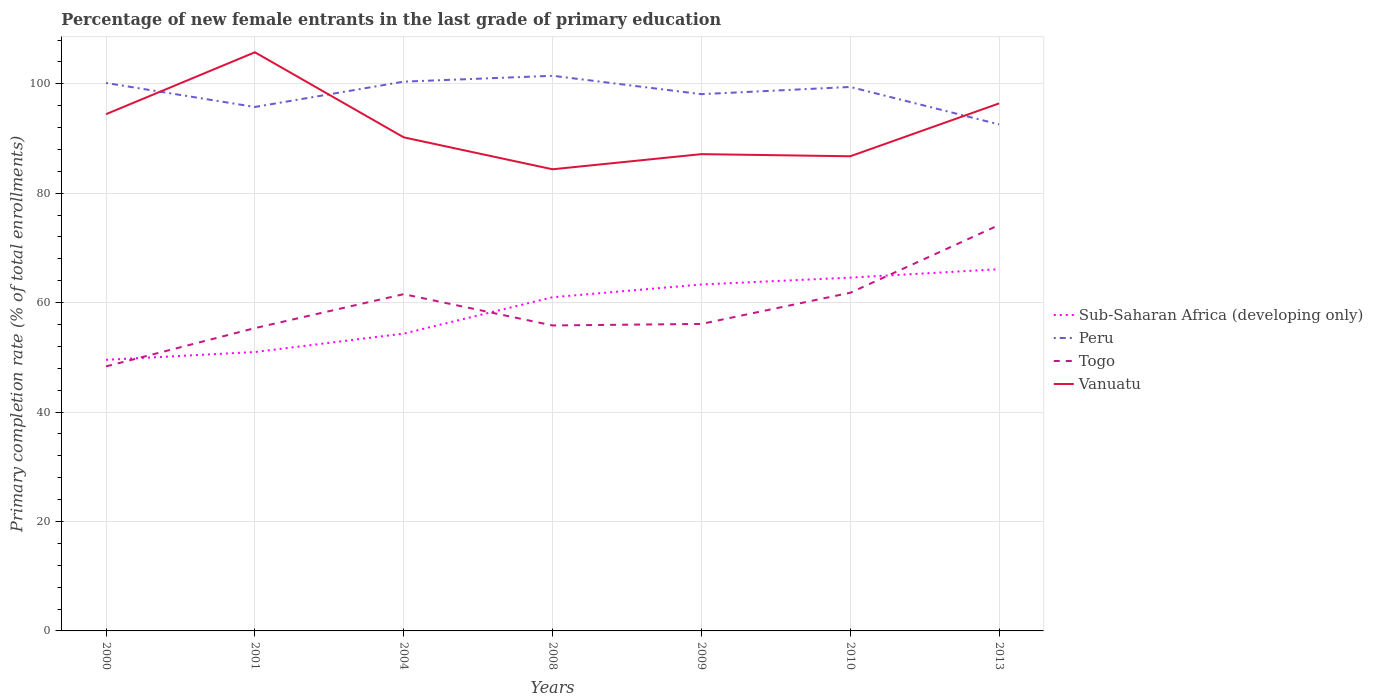Does the line corresponding to Peru intersect with the line corresponding to Togo?
Your answer should be compact. No. Across all years, what is the maximum percentage of new female entrants in Vanuatu?
Provide a succinct answer. 84.37. What is the total percentage of new female entrants in Peru in the graph?
Provide a succinct answer. -1.07. What is the difference between the highest and the second highest percentage of new female entrants in Peru?
Your answer should be very brief. 8.89. What is the difference between the highest and the lowest percentage of new female entrants in Vanuatu?
Your answer should be very brief. 3. How many years are there in the graph?
Offer a terse response. 7. Does the graph contain grids?
Give a very brief answer. Yes. What is the title of the graph?
Provide a short and direct response. Percentage of new female entrants in the last grade of primary education. What is the label or title of the Y-axis?
Offer a terse response. Primary completion rate (% of total enrollments). What is the Primary completion rate (% of total enrollments) in Sub-Saharan Africa (developing only) in 2000?
Keep it short and to the point. 49.55. What is the Primary completion rate (% of total enrollments) in Peru in 2000?
Your answer should be very brief. 100.15. What is the Primary completion rate (% of total enrollments) of Togo in 2000?
Ensure brevity in your answer.  48.34. What is the Primary completion rate (% of total enrollments) of Vanuatu in 2000?
Your response must be concise. 94.44. What is the Primary completion rate (% of total enrollments) in Sub-Saharan Africa (developing only) in 2001?
Offer a very short reply. 50.98. What is the Primary completion rate (% of total enrollments) of Peru in 2001?
Ensure brevity in your answer.  95.76. What is the Primary completion rate (% of total enrollments) in Togo in 2001?
Your response must be concise. 55.34. What is the Primary completion rate (% of total enrollments) in Vanuatu in 2001?
Ensure brevity in your answer.  105.76. What is the Primary completion rate (% of total enrollments) of Sub-Saharan Africa (developing only) in 2004?
Offer a terse response. 54.34. What is the Primary completion rate (% of total enrollments) of Peru in 2004?
Your response must be concise. 100.39. What is the Primary completion rate (% of total enrollments) of Togo in 2004?
Offer a very short reply. 61.55. What is the Primary completion rate (% of total enrollments) of Vanuatu in 2004?
Ensure brevity in your answer.  90.21. What is the Primary completion rate (% of total enrollments) in Sub-Saharan Africa (developing only) in 2008?
Make the answer very short. 60.99. What is the Primary completion rate (% of total enrollments) in Peru in 2008?
Offer a very short reply. 101.46. What is the Primary completion rate (% of total enrollments) of Togo in 2008?
Your answer should be compact. 55.83. What is the Primary completion rate (% of total enrollments) in Vanuatu in 2008?
Offer a very short reply. 84.37. What is the Primary completion rate (% of total enrollments) of Sub-Saharan Africa (developing only) in 2009?
Give a very brief answer. 63.32. What is the Primary completion rate (% of total enrollments) of Peru in 2009?
Ensure brevity in your answer.  98.1. What is the Primary completion rate (% of total enrollments) in Togo in 2009?
Make the answer very short. 56.11. What is the Primary completion rate (% of total enrollments) of Vanuatu in 2009?
Provide a succinct answer. 87.14. What is the Primary completion rate (% of total enrollments) in Sub-Saharan Africa (developing only) in 2010?
Provide a short and direct response. 64.57. What is the Primary completion rate (% of total enrollments) of Peru in 2010?
Keep it short and to the point. 99.42. What is the Primary completion rate (% of total enrollments) of Togo in 2010?
Your answer should be very brief. 61.81. What is the Primary completion rate (% of total enrollments) of Vanuatu in 2010?
Keep it short and to the point. 86.75. What is the Primary completion rate (% of total enrollments) of Sub-Saharan Africa (developing only) in 2013?
Ensure brevity in your answer.  66.11. What is the Primary completion rate (% of total enrollments) in Peru in 2013?
Ensure brevity in your answer.  92.57. What is the Primary completion rate (% of total enrollments) of Togo in 2013?
Offer a terse response. 74.2. What is the Primary completion rate (% of total enrollments) of Vanuatu in 2013?
Ensure brevity in your answer.  96.41. Across all years, what is the maximum Primary completion rate (% of total enrollments) of Sub-Saharan Africa (developing only)?
Keep it short and to the point. 66.11. Across all years, what is the maximum Primary completion rate (% of total enrollments) in Peru?
Give a very brief answer. 101.46. Across all years, what is the maximum Primary completion rate (% of total enrollments) of Togo?
Offer a very short reply. 74.2. Across all years, what is the maximum Primary completion rate (% of total enrollments) in Vanuatu?
Give a very brief answer. 105.76. Across all years, what is the minimum Primary completion rate (% of total enrollments) of Sub-Saharan Africa (developing only)?
Provide a succinct answer. 49.55. Across all years, what is the minimum Primary completion rate (% of total enrollments) of Peru?
Provide a succinct answer. 92.57. Across all years, what is the minimum Primary completion rate (% of total enrollments) in Togo?
Your response must be concise. 48.34. Across all years, what is the minimum Primary completion rate (% of total enrollments) of Vanuatu?
Your answer should be very brief. 84.37. What is the total Primary completion rate (% of total enrollments) of Sub-Saharan Africa (developing only) in the graph?
Keep it short and to the point. 409.85. What is the total Primary completion rate (% of total enrollments) in Peru in the graph?
Your answer should be very brief. 687.86. What is the total Primary completion rate (% of total enrollments) in Togo in the graph?
Make the answer very short. 413.18. What is the total Primary completion rate (% of total enrollments) in Vanuatu in the graph?
Your answer should be very brief. 645.09. What is the difference between the Primary completion rate (% of total enrollments) of Sub-Saharan Africa (developing only) in 2000 and that in 2001?
Your response must be concise. -1.43. What is the difference between the Primary completion rate (% of total enrollments) of Peru in 2000 and that in 2001?
Your answer should be very brief. 4.39. What is the difference between the Primary completion rate (% of total enrollments) of Togo in 2000 and that in 2001?
Keep it short and to the point. -7. What is the difference between the Primary completion rate (% of total enrollments) in Vanuatu in 2000 and that in 2001?
Offer a terse response. -11.31. What is the difference between the Primary completion rate (% of total enrollments) of Sub-Saharan Africa (developing only) in 2000 and that in 2004?
Provide a succinct answer. -4.79. What is the difference between the Primary completion rate (% of total enrollments) in Peru in 2000 and that in 2004?
Offer a very short reply. -0.24. What is the difference between the Primary completion rate (% of total enrollments) in Togo in 2000 and that in 2004?
Provide a succinct answer. -13.21. What is the difference between the Primary completion rate (% of total enrollments) in Vanuatu in 2000 and that in 2004?
Your response must be concise. 4.24. What is the difference between the Primary completion rate (% of total enrollments) in Sub-Saharan Africa (developing only) in 2000 and that in 2008?
Offer a terse response. -11.44. What is the difference between the Primary completion rate (% of total enrollments) in Peru in 2000 and that in 2008?
Provide a short and direct response. -1.31. What is the difference between the Primary completion rate (% of total enrollments) in Togo in 2000 and that in 2008?
Provide a short and direct response. -7.49. What is the difference between the Primary completion rate (% of total enrollments) in Vanuatu in 2000 and that in 2008?
Your response must be concise. 10.07. What is the difference between the Primary completion rate (% of total enrollments) in Sub-Saharan Africa (developing only) in 2000 and that in 2009?
Offer a very short reply. -13.77. What is the difference between the Primary completion rate (% of total enrollments) of Peru in 2000 and that in 2009?
Provide a succinct answer. 2.05. What is the difference between the Primary completion rate (% of total enrollments) in Togo in 2000 and that in 2009?
Keep it short and to the point. -7.77. What is the difference between the Primary completion rate (% of total enrollments) of Vanuatu in 2000 and that in 2009?
Keep it short and to the point. 7.3. What is the difference between the Primary completion rate (% of total enrollments) of Sub-Saharan Africa (developing only) in 2000 and that in 2010?
Ensure brevity in your answer.  -15.02. What is the difference between the Primary completion rate (% of total enrollments) of Peru in 2000 and that in 2010?
Keep it short and to the point. 0.73. What is the difference between the Primary completion rate (% of total enrollments) of Togo in 2000 and that in 2010?
Your response must be concise. -13.46. What is the difference between the Primary completion rate (% of total enrollments) of Vanuatu in 2000 and that in 2010?
Offer a very short reply. 7.69. What is the difference between the Primary completion rate (% of total enrollments) in Sub-Saharan Africa (developing only) in 2000 and that in 2013?
Your answer should be compact. -16.57. What is the difference between the Primary completion rate (% of total enrollments) in Peru in 2000 and that in 2013?
Your answer should be very brief. 7.57. What is the difference between the Primary completion rate (% of total enrollments) in Togo in 2000 and that in 2013?
Provide a succinct answer. -25.86. What is the difference between the Primary completion rate (% of total enrollments) in Vanuatu in 2000 and that in 2013?
Make the answer very short. -1.97. What is the difference between the Primary completion rate (% of total enrollments) in Sub-Saharan Africa (developing only) in 2001 and that in 2004?
Provide a short and direct response. -3.36. What is the difference between the Primary completion rate (% of total enrollments) in Peru in 2001 and that in 2004?
Provide a succinct answer. -4.63. What is the difference between the Primary completion rate (% of total enrollments) in Togo in 2001 and that in 2004?
Make the answer very short. -6.2. What is the difference between the Primary completion rate (% of total enrollments) in Vanuatu in 2001 and that in 2004?
Provide a succinct answer. 15.55. What is the difference between the Primary completion rate (% of total enrollments) in Sub-Saharan Africa (developing only) in 2001 and that in 2008?
Your response must be concise. -10.01. What is the difference between the Primary completion rate (% of total enrollments) in Peru in 2001 and that in 2008?
Ensure brevity in your answer.  -5.7. What is the difference between the Primary completion rate (% of total enrollments) in Togo in 2001 and that in 2008?
Your answer should be very brief. -0.48. What is the difference between the Primary completion rate (% of total enrollments) of Vanuatu in 2001 and that in 2008?
Offer a very short reply. 21.38. What is the difference between the Primary completion rate (% of total enrollments) of Sub-Saharan Africa (developing only) in 2001 and that in 2009?
Your response must be concise. -12.34. What is the difference between the Primary completion rate (% of total enrollments) of Peru in 2001 and that in 2009?
Give a very brief answer. -2.34. What is the difference between the Primary completion rate (% of total enrollments) in Togo in 2001 and that in 2009?
Keep it short and to the point. -0.76. What is the difference between the Primary completion rate (% of total enrollments) in Vanuatu in 2001 and that in 2009?
Give a very brief answer. 18.62. What is the difference between the Primary completion rate (% of total enrollments) in Sub-Saharan Africa (developing only) in 2001 and that in 2010?
Ensure brevity in your answer.  -13.6. What is the difference between the Primary completion rate (% of total enrollments) of Peru in 2001 and that in 2010?
Provide a short and direct response. -3.66. What is the difference between the Primary completion rate (% of total enrollments) in Togo in 2001 and that in 2010?
Give a very brief answer. -6.46. What is the difference between the Primary completion rate (% of total enrollments) of Vanuatu in 2001 and that in 2010?
Provide a succinct answer. 19. What is the difference between the Primary completion rate (% of total enrollments) of Sub-Saharan Africa (developing only) in 2001 and that in 2013?
Ensure brevity in your answer.  -15.14. What is the difference between the Primary completion rate (% of total enrollments) in Peru in 2001 and that in 2013?
Provide a short and direct response. 3.19. What is the difference between the Primary completion rate (% of total enrollments) in Togo in 2001 and that in 2013?
Keep it short and to the point. -18.85. What is the difference between the Primary completion rate (% of total enrollments) in Vanuatu in 2001 and that in 2013?
Keep it short and to the point. 9.34. What is the difference between the Primary completion rate (% of total enrollments) of Sub-Saharan Africa (developing only) in 2004 and that in 2008?
Provide a succinct answer. -6.64. What is the difference between the Primary completion rate (% of total enrollments) in Peru in 2004 and that in 2008?
Make the answer very short. -1.07. What is the difference between the Primary completion rate (% of total enrollments) of Togo in 2004 and that in 2008?
Make the answer very short. 5.72. What is the difference between the Primary completion rate (% of total enrollments) in Vanuatu in 2004 and that in 2008?
Your response must be concise. 5.84. What is the difference between the Primary completion rate (% of total enrollments) of Sub-Saharan Africa (developing only) in 2004 and that in 2009?
Provide a succinct answer. -8.98. What is the difference between the Primary completion rate (% of total enrollments) in Peru in 2004 and that in 2009?
Ensure brevity in your answer.  2.29. What is the difference between the Primary completion rate (% of total enrollments) in Togo in 2004 and that in 2009?
Give a very brief answer. 5.44. What is the difference between the Primary completion rate (% of total enrollments) of Vanuatu in 2004 and that in 2009?
Your response must be concise. 3.07. What is the difference between the Primary completion rate (% of total enrollments) in Sub-Saharan Africa (developing only) in 2004 and that in 2010?
Ensure brevity in your answer.  -10.23. What is the difference between the Primary completion rate (% of total enrollments) of Peru in 2004 and that in 2010?
Make the answer very short. 0.97. What is the difference between the Primary completion rate (% of total enrollments) in Togo in 2004 and that in 2010?
Offer a terse response. -0.26. What is the difference between the Primary completion rate (% of total enrollments) of Vanuatu in 2004 and that in 2010?
Give a very brief answer. 3.46. What is the difference between the Primary completion rate (% of total enrollments) in Sub-Saharan Africa (developing only) in 2004 and that in 2013?
Ensure brevity in your answer.  -11.77. What is the difference between the Primary completion rate (% of total enrollments) of Peru in 2004 and that in 2013?
Make the answer very short. 7.82. What is the difference between the Primary completion rate (% of total enrollments) of Togo in 2004 and that in 2013?
Offer a very short reply. -12.65. What is the difference between the Primary completion rate (% of total enrollments) in Vanuatu in 2004 and that in 2013?
Ensure brevity in your answer.  -6.2. What is the difference between the Primary completion rate (% of total enrollments) in Sub-Saharan Africa (developing only) in 2008 and that in 2009?
Make the answer very short. -2.33. What is the difference between the Primary completion rate (% of total enrollments) in Peru in 2008 and that in 2009?
Provide a succinct answer. 3.36. What is the difference between the Primary completion rate (% of total enrollments) in Togo in 2008 and that in 2009?
Make the answer very short. -0.28. What is the difference between the Primary completion rate (% of total enrollments) in Vanuatu in 2008 and that in 2009?
Your answer should be compact. -2.77. What is the difference between the Primary completion rate (% of total enrollments) in Sub-Saharan Africa (developing only) in 2008 and that in 2010?
Make the answer very short. -3.59. What is the difference between the Primary completion rate (% of total enrollments) of Peru in 2008 and that in 2010?
Ensure brevity in your answer.  2.04. What is the difference between the Primary completion rate (% of total enrollments) of Togo in 2008 and that in 2010?
Offer a terse response. -5.98. What is the difference between the Primary completion rate (% of total enrollments) of Vanuatu in 2008 and that in 2010?
Give a very brief answer. -2.38. What is the difference between the Primary completion rate (% of total enrollments) of Sub-Saharan Africa (developing only) in 2008 and that in 2013?
Give a very brief answer. -5.13. What is the difference between the Primary completion rate (% of total enrollments) in Peru in 2008 and that in 2013?
Provide a succinct answer. 8.89. What is the difference between the Primary completion rate (% of total enrollments) in Togo in 2008 and that in 2013?
Your answer should be compact. -18.37. What is the difference between the Primary completion rate (% of total enrollments) of Vanuatu in 2008 and that in 2013?
Ensure brevity in your answer.  -12.04. What is the difference between the Primary completion rate (% of total enrollments) in Sub-Saharan Africa (developing only) in 2009 and that in 2010?
Provide a succinct answer. -1.25. What is the difference between the Primary completion rate (% of total enrollments) of Peru in 2009 and that in 2010?
Ensure brevity in your answer.  -1.32. What is the difference between the Primary completion rate (% of total enrollments) of Togo in 2009 and that in 2010?
Offer a terse response. -5.7. What is the difference between the Primary completion rate (% of total enrollments) in Vanuatu in 2009 and that in 2010?
Your response must be concise. 0.39. What is the difference between the Primary completion rate (% of total enrollments) of Sub-Saharan Africa (developing only) in 2009 and that in 2013?
Provide a short and direct response. -2.79. What is the difference between the Primary completion rate (% of total enrollments) in Peru in 2009 and that in 2013?
Ensure brevity in your answer.  5.53. What is the difference between the Primary completion rate (% of total enrollments) in Togo in 2009 and that in 2013?
Keep it short and to the point. -18.09. What is the difference between the Primary completion rate (% of total enrollments) in Vanuatu in 2009 and that in 2013?
Your response must be concise. -9.27. What is the difference between the Primary completion rate (% of total enrollments) in Sub-Saharan Africa (developing only) in 2010 and that in 2013?
Ensure brevity in your answer.  -1.54. What is the difference between the Primary completion rate (% of total enrollments) in Peru in 2010 and that in 2013?
Offer a very short reply. 6.85. What is the difference between the Primary completion rate (% of total enrollments) in Togo in 2010 and that in 2013?
Your answer should be compact. -12.39. What is the difference between the Primary completion rate (% of total enrollments) of Vanuatu in 2010 and that in 2013?
Your answer should be very brief. -9.66. What is the difference between the Primary completion rate (% of total enrollments) in Sub-Saharan Africa (developing only) in 2000 and the Primary completion rate (% of total enrollments) in Peru in 2001?
Provide a succinct answer. -46.22. What is the difference between the Primary completion rate (% of total enrollments) of Sub-Saharan Africa (developing only) in 2000 and the Primary completion rate (% of total enrollments) of Togo in 2001?
Provide a succinct answer. -5.8. What is the difference between the Primary completion rate (% of total enrollments) in Sub-Saharan Africa (developing only) in 2000 and the Primary completion rate (% of total enrollments) in Vanuatu in 2001?
Give a very brief answer. -56.21. What is the difference between the Primary completion rate (% of total enrollments) of Peru in 2000 and the Primary completion rate (% of total enrollments) of Togo in 2001?
Keep it short and to the point. 44.8. What is the difference between the Primary completion rate (% of total enrollments) in Peru in 2000 and the Primary completion rate (% of total enrollments) in Vanuatu in 2001?
Your response must be concise. -5.61. What is the difference between the Primary completion rate (% of total enrollments) in Togo in 2000 and the Primary completion rate (% of total enrollments) in Vanuatu in 2001?
Keep it short and to the point. -57.41. What is the difference between the Primary completion rate (% of total enrollments) of Sub-Saharan Africa (developing only) in 2000 and the Primary completion rate (% of total enrollments) of Peru in 2004?
Keep it short and to the point. -50.84. What is the difference between the Primary completion rate (% of total enrollments) in Sub-Saharan Africa (developing only) in 2000 and the Primary completion rate (% of total enrollments) in Togo in 2004?
Offer a terse response. -12. What is the difference between the Primary completion rate (% of total enrollments) of Sub-Saharan Africa (developing only) in 2000 and the Primary completion rate (% of total enrollments) of Vanuatu in 2004?
Keep it short and to the point. -40.66. What is the difference between the Primary completion rate (% of total enrollments) in Peru in 2000 and the Primary completion rate (% of total enrollments) in Togo in 2004?
Offer a terse response. 38.6. What is the difference between the Primary completion rate (% of total enrollments) in Peru in 2000 and the Primary completion rate (% of total enrollments) in Vanuatu in 2004?
Your response must be concise. 9.94. What is the difference between the Primary completion rate (% of total enrollments) in Togo in 2000 and the Primary completion rate (% of total enrollments) in Vanuatu in 2004?
Provide a succinct answer. -41.87. What is the difference between the Primary completion rate (% of total enrollments) in Sub-Saharan Africa (developing only) in 2000 and the Primary completion rate (% of total enrollments) in Peru in 2008?
Your response must be concise. -51.91. What is the difference between the Primary completion rate (% of total enrollments) in Sub-Saharan Africa (developing only) in 2000 and the Primary completion rate (% of total enrollments) in Togo in 2008?
Offer a very short reply. -6.28. What is the difference between the Primary completion rate (% of total enrollments) of Sub-Saharan Africa (developing only) in 2000 and the Primary completion rate (% of total enrollments) of Vanuatu in 2008?
Provide a succinct answer. -34.83. What is the difference between the Primary completion rate (% of total enrollments) of Peru in 2000 and the Primary completion rate (% of total enrollments) of Togo in 2008?
Provide a short and direct response. 44.32. What is the difference between the Primary completion rate (% of total enrollments) of Peru in 2000 and the Primary completion rate (% of total enrollments) of Vanuatu in 2008?
Your answer should be very brief. 15.78. What is the difference between the Primary completion rate (% of total enrollments) of Togo in 2000 and the Primary completion rate (% of total enrollments) of Vanuatu in 2008?
Your response must be concise. -36.03. What is the difference between the Primary completion rate (% of total enrollments) in Sub-Saharan Africa (developing only) in 2000 and the Primary completion rate (% of total enrollments) in Peru in 2009?
Your response must be concise. -48.55. What is the difference between the Primary completion rate (% of total enrollments) in Sub-Saharan Africa (developing only) in 2000 and the Primary completion rate (% of total enrollments) in Togo in 2009?
Make the answer very short. -6.56. What is the difference between the Primary completion rate (% of total enrollments) of Sub-Saharan Africa (developing only) in 2000 and the Primary completion rate (% of total enrollments) of Vanuatu in 2009?
Your answer should be compact. -37.59. What is the difference between the Primary completion rate (% of total enrollments) in Peru in 2000 and the Primary completion rate (% of total enrollments) in Togo in 2009?
Provide a short and direct response. 44.04. What is the difference between the Primary completion rate (% of total enrollments) in Peru in 2000 and the Primary completion rate (% of total enrollments) in Vanuatu in 2009?
Give a very brief answer. 13.01. What is the difference between the Primary completion rate (% of total enrollments) of Togo in 2000 and the Primary completion rate (% of total enrollments) of Vanuatu in 2009?
Offer a very short reply. -38.8. What is the difference between the Primary completion rate (% of total enrollments) of Sub-Saharan Africa (developing only) in 2000 and the Primary completion rate (% of total enrollments) of Peru in 2010?
Give a very brief answer. -49.87. What is the difference between the Primary completion rate (% of total enrollments) in Sub-Saharan Africa (developing only) in 2000 and the Primary completion rate (% of total enrollments) in Togo in 2010?
Give a very brief answer. -12.26. What is the difference between the Primary completion rate (% of total enrollments) in Sub-Saharan Africa (developing only) in 2000 and the Primary completion rate (% of total enrollments) in Vanuatu in 2010?
Make the answer very short. -37.2. What is the difference between the Primary completion rate (% of total enrollments) in Peru in 2000 and the Primary completion rate (% of total enrollments) in Togo in 2010?
Your answer should be very brief. 38.34. What is the difference between the Primary completion rate (% of total enrollments) of Peru in 2000 and the Primary completion rate (% of total enrollments) of Vanuatu in 2010?
Your response must be concise. 13.4. What is the difference between the Primary completion rate (% of total enrollments) of Togo in 2000 and the Primary completion rate (% of total enrollments) of Vanuatu in 2010?
Your answer should be very brief. -38.41. What is the difference between the Primary completion rate (% of total enrollments) in Sub-Saharan Africa (developing only) in 2000 and the Primary completion rate (% of total enrollments) in Peru in 2013?
Give a very brief answer. -43.03. What is the difference between the Primary completion rate (% of total enrollments) of Sub-Saharan Africa (developing only) in 2000 and the Primary completion rate (% of total enrollments) of Togo in 2013?
Your answer should be very brief. -24.65. What is the difference between the Primary completion rate (% of total enrollments) in Sub-Saharan Africa (developing only) in 2000 and the Primary completion rate (% of total enrollments) in Vanuatu in 2013?
Offer a very short reply. -46.87. What is the difference between the Primary completion rate (% of total enrollments) of Peru in 2000 and the Primary completion rate (% of total enrollments) of Togo in 2013?
Provide a succinct answer. 25.95. What is the difference between the Primary completion rate (% of total enrollments) of Peru in 2000 and the Primary completion rate (% of total enrollments) of Vanuatu in 2013?
Your response must be concise. 3.74. What is the difference between the Primary completion rate (% of total enrollments) of Togo in 2000 and the Primary completion rate (% of total enrollments) of Vanuatu in 2013?
Provide a short and direct response. -48.07. What is the difference between the Primary completion rate (% of total enrollments) in Sub-Saharan Africa (developing only) in 2001 and the Primary completion rate (% of total enrollments) in Peru in 2004?
Ensure brevity in your answer.  -49.41. What is the difference between the Primary completion rate (% of total enrollments) in Sub-Saharan Africa (developing only) in 2001 and the Primary completion rate (% of total enrollments) in Togo in 2004?
Your response must be concise. -10.57. What is the difference between the Primary completion rate (% of total enrollments) in Sub-Saharan Africa (developing only) in 2001 and the Primary completion rate (% of total enrollments) in Vanuatu in 2004?
Keep it short and to the point. -39.23. What is the difference between the Primary completion rate (% of total enrollments) of Peru in 2001 and the Primary completion rate (% of total enrollments) of Togo in 2004?
Offer a very short reply. 34.21. What is the difference between the Primary completion rate (% of total enrollments) in Peru in 2001 and the Primary completion rate (% of total enrollments) in Vanuatu in 2004?
Give a very brief answer. 5.55. What is the difference between the Primary completion rate (% of total enrollments) of Togo in 2001 and the Primary completion rate (% of total enrollments) of Vanuatu in 2004?
Offer a very short reply. -34.86. What is the difference between the Primary completion rate (% of total enrollments) of Sub-Saharan Africa (developing only) in 2001 and the Primary completion rate (% of total enrollments) of Peru in 2008?
Provide a short and direct response. -50.49. What is the difference between the Primary completion rate (% of total enrollments) in Sub-Saharan Africa (developing only) in 2001 and the Primary completion rate (% of total enrollments) in Togo in 2008?
Ensure brevity in your answer.  -4.85. What is the difference between the Primary completion rate (% of total enrollments) in Sub-Saharan Africa (developing only) in 2001 and the Primary completion rate (% of total enrollments) in Vanuatu in 2008?
Give a very brief answer. -33.4. What is the difference between the Primary completion rate (% of total enrollments) of Peru in 2001 and the Primary completion rate (% of total enrollments) of Togo in 2008?
Your answer should be compact. 39.93. What is the difference between the Primary completion rate (% of total enrollments) of Peru in 2001 and the Primary completion rate (% of total enrollments) of Vanuatu in 2008?
Give a very brief answer. 11.39. What is the difference between the Primary completion rate (% of total enrollments) in Togo in 2001 and the Primary completion rate (% of total enrollments) in Vanuatu in 2008?
Your response must be concise. -29.03. What is the difference between the Primary completion rate (% of total enrollments) in Sub-Saharan Africa (developing only) in 2001 and the Primary completion rate (% of total enrollments) in Peru in 2009?
Keep it short and to the point. -47.13. What is the difference between the Primary completion rate (% of total enrollments) in Sub-Saharan Africa (developing only) in 2001 and the Primary completion rate (% of total enrollments) in Togo in 2009?
Offer a very short reply. -5.13. What is the difference between the Primary completion rate (% of total enrollments) in Sub-Saharan Africa (developing only) in 2001 and the Primary completion rate (% of total enrollments) in Vanuatu in 2009?
Provide a short and direct response. -36.16. What is the difference between the Primary completion rate (% of total enrollments) in Peru in 2001 and the Primary completion rate (% of total enrollments) in Togo in 2009?
Offer a very short reply. 39.65. What is the difference between the Primary completion rate (% of total enrollments) of Peru in 2001 and the Primary completion rate (% of total enrollments) of Vanuatu in 2009?
Your response must be concise. 8.62. What is the difference between the Primary completion rate (% of total enrollments) of Togo in 2001 and the Primary completion rate (% of total enrollments) of Vanuatu in 2009?
Your answer should be very brief. -31.8. What is the difference between the Primary completion rate (% of total enrollments) of Sub-Saharan Africa (developing only) in 2001 and the Primary completion rate (% of total enrollments) of Peru in 2010?
Offer a terse response. -48.44. What is the difference between the Primary completion rate (% of total enrollments) in Sub-Saharan Africa (developing only) in 2001 and the Primary completion rate (% of total enrollments) in Togo in 2010?
Your response must be concise. -10.83. What is the difference between the Primary completion rate (% of total enrollments) of Sub-Saharan Africa (developing only) in 2001 and the Primary completion rate (% of total enrollments) of Vanuatu in 2010?
Provide a short and direct response. -35.78. What is the difference between the Primary completion rate (% of total enrollments) in Peru in 2001 and the Primary completion rate (% of total enrollments) in Togo in 2010?
Ensure brevity in your answer.  33.96. What is the difference between the Primary completion rate (% of total enrollments) of Peru in 2001 and the Primary completion rate (% of total enrollments) of Vanuatu in 2010?
Offer a very short reply. 9.01. What is the difference between the Primary completion rate (% of total enrollments) in Togo in 2001 and the Primary completion rate (% of total enrollments) in Vanuatu in 2010?
Keep it short and to the point. -31.41. What is the difference between the Primary completion rate (% of total enrollments) of Sub-Saharan Africa (developing only) in 2001 and the Primary completion rate (% of total enrollments) of Peru in 2013?
Give a very brief answer. -41.6. What is the difference between the Primary completion rate (% of total enrollments) in Sub-Saharan Africa (developing only) in 2001 and the Primary completion rate (% of total enrollments) in Togo in 2013?
Offer a terse response. -23.22. What is the difference between the Primary completion rate (% of total enrollments) of Sub-Saharan Africa (developing only) in 2001 and the Primary completion rate (% of total enrollments) of Vanuatu in 2013?
Your response must be concise. -45.44. What is the difference between the Primary completion rate (% of total enrollments) in Peru in 2001 and the Primary completion rate (% of total enrollments) in Togo in 2013?
Provide a succinct answer. 21.56. What is the difference between the Primary completion rate (% of total enrollments) in Peru in 2001 and the Primary completion rate (% of total enrollments) in Vanuatu in 2013?
Your response must be concise. -0.65. What is the difference between the Primary completion rate (% of total enrollments) of Togo in 2001 and the Primary completion rate (% of total enrollments) of Vanuatu in 2013?
Provide a short and direct response. -41.07. What is the difference between the Primary completion rate (% of total enrollments) of Sub-Saharan Africa (developing only) in 2004 and the Primary completion rate (% of total enrollments) of Peru in 2008?
Provide a short and direct response. -47.12. What is the difference between the Primary completion rate (% of total enrollments) of Sub-Saharan Africa (developing only) in 2004 and the Primary completion rate (% of total enrollments) of Togo in 2008?
Give a very brief answer. -1.49. What is the difference between the Primary completion rate (% of total enrollments) of Sub-Saharan Africa (developing only) in 2004 and the Primary completion rate (% of total enrollments) of Vanuatu in 2008?
Ensure brevity in your answer.  -30.03. What is the difference between the Primary completion rate (% of total enrollments) in Peru in 2004 and the Primary completion rate (% of total enrollments) in Togo in 2008?
Your answer should be compact. 44.56. What is the difference between the Primary completion rate (% of total enrollments) of Peru in 2004 and the Primary completion rate (% of total enrollments) of Vanuatu in 2008?
Offer a very short reply. 16.02. What is the difference between the Primary completion rate (% of total enrollments) of Togo in 2004 and the Primary completion rate (% of total enrollments) of Vanuatu in 2008?
Your answer should be compact. -22.82. What is the difference between the Primary completion rate (% of total enrollments) of Sub-Saharan Africa (developing only) in 2004 and the Primary completion rate (% of total enrollments) of Peru in 2009?
Your response must be concise. -43.76. What is the difference between the Primary completion rate (% of total enrollments) of Sub-Saharan Africa (developing only) in 2004 and the Primary completion rate (% of total enrollments) of Togo in 2009?
Offer a very short reply. -1.77. What is the difference between the Primary completion rate (% of total enrollments) in Sub-Saharan Africa (developing only) in 2004 and the Primary completion rate (% of total enrollments) in Vanuatu in 2009?
Ensure brevity in your answer.  -32.8. What is the difference between the Primary completion rate (% of total enrollments) of Peru in 2004 and the Primary completion rate (% of total enrollments) of Togo in 2009?
Give a very brief answer. 44.28. What is the difference between the Primary completion rate (% of total enrollments) of Peru in 2004 and the Primary completion rate (% of total enrollments) of Vanuatu in 2009?
Your answer should be very brief. 13.25. What is the difference between the Primary completion rate (% of total enrollments) in Togo in 2004 and the Primary completion rate (% of total enrollments) in Vanuatu in 2009?
Provide a short and direct response. -25.59. What is the difference between the Primary completion rate (% of total enrollments) in Sub-Saharan Africa (developing only) in 2004 and the Primary completion rate (% of total enrollments) in Peru in 2010?
Give a very brief answer. -45.08. What is the difference between the Primary completion rate (% of total enrollments) of Sub-Saharan Africa (developing only) in 2004 and the Primary completion rate (% of total enrollments) of Togo in 2010?
Provide a short and direct response. -7.47. What is the difference between the Primary completion rate (% of total enrollments) of Sub-Saharan Africa (developing only) in 2004 and the Primary completion rate (% of total enrollments) of Vanuatu in 2010?
Your answer should be very brief. -32.41. What is the difference between the Primary completion rate (% of total enrollments) in Peru in 2004 and the Primary completion rate (% of total enrollments) in Togo in 2010?
Your response must be concise. 38.58. What is the difference between the Primary completion rate (% of total enrollments) of Peru in 2004 and the Primary completion rate (% of total enrollments) of Vanuatu in 2010?
Offer a very short reply. 13.64. What is the difference between the Primary completion rate (% of total enrollments) of Togo in 2004 and the Primary completion rate (% of total enrollments) of Vanuatu in 2010?
Ensure brevity in your answer.  -25.2. What is the difference between the Primary completion rate (% of total enrollments) of Sub-Saharan Africa (developing only) in 2004 and the Primary completion rate (% of total enrollments) of Peru in 2013?
Provide a short and direct response. -38.23. What is the difference between the Primary completion rate (% of total enrollments) in Sub-Saharan Africa (developing only) in 2004 and the Primary completion rate (% of total enrollments) in Togo in 2013?
Give a very brief answer. -19.86. What is the difference between the Primary completion rate (% of total enrollments) of Sub-Saharan Africa (developing only) in 2004 and the Primary completion rate (% of total enrollments) of Vanuatu in 2013?
Provide a short and direct response. -42.07. What is the difference between the Primary completion rate (% of total enrollments) in Peru in 2004 and the Primary completion rate (% of total enrollments) in Togo in 2013?
Your response must be concise. 26.19. What is the difference between the Primary completion rate (% of total enrollments) in Peru in 2004 and the Primary completion rate (% of total enrollments) in Vanuatu in 2013?
Ensure brevity in your answer.  3.98. What is the difference between the Primary completion rate (% of total enrollments) in Togo in 2004 and the Primary completion rate (% of total enrollments) in Vanuatu in 2013?
Keep it short and to the point. -34.86. What is the difference between the Primary completion rate (% of total enrollments) of Sub-Saharan Africa (developing only) in 2008 and the Primary completion rate (% of total enrollments) of Peru in 2009?
Your answer should be compact. -37.12. What is the difference between the Primary completion rate (% of total enrollments) in Sub-Saharan Africa (developing only) in 2008 and the Primary completion rate (% of total enrollments) in Togo in 2009?
Provide a short and direct response. 4.88. What is the difference between the Primary completion rate (% of total enrollments) of Sub-Saharan Africa (developing only) in 2008 and the Primary completion rate (% of total enrollments) of Vanuatu in 2009?
Offer a very short reply. -26.16. What is the difference between the Primary completion rate (% of total enrollments) of Peru in 2008 and the Primary completion rate (% of total enrollments) of Togo in 2009?
Provide a succinct answer. 45.35. What is the difference between the Primary completion rate (% of total enrollments) in Peru in 2008 and the Primary completion rate (% of total enrollments) in Vanuatu in 2009?
Offer a terse response. 14.32. What is the difference between the Primary completion rate (% of total enrollments) in Togo in 2008 and the Primary completion rate (% of total enrollments) in Vanuatu in 2009?
Offer a terse response. -31.31. What is the difference between the Primary completion rate (% of total enrollments) of Sub-Saharan Africa (developing only) in 2008 and the Primary completion rate (% of total enrollments) of Peru in 2010?
Your answer should be very brief. -38.43. What is the difference between the Primary completion rate (% of total enrollments) of Sub-Saharan Africa (developing only) in 2008 and the Primary completion rate (% of total enrollments) of Togo in 2010?
Your answer should be compact. -0.82. What is the difference between the Primary completion rate (% of total enrollments) of Sub-Saharan Africa (developing only) in 2008 and the Primary completion rate (% of total enrollments) of Vanuatu in 2010?
Your response must be concise. -25.77. What is the difference between the Primary completion rate (% of total enrollments) of Peru in 2008 and the Primary completion rate (% of total enrollments) of Togo in 2010?
Provide a short and direct response. 39.66. What is the difference between the Primary completion rate (% of total enrollments) of Peru in 2008 and the Primary completion rate (% of total enrollments) of Vanuatu in 2010?
Your response must be concise. 14.71. What is the difference between the Primary completion rate (% of total enrollments) in Togo in 2008 and the Primary completion rate (% of total enrollments) in Vanuatu in 2010?
Your answer should be very brief. -30.92. What is the difference between the Primary completion rate (% of total enrollments) of Sub-Saharan Africa (developing only) in 2008 and the Primary completion rate (% of total enrollments) of Peru in 2013?
Offer a terse response. -31.59. What is the difference between the Primary completion rate (% of total enrollments) of Sub-Saharan Africa (developing only) in 2008 and the Primary completion rate (% of total enrollments) of Togo in 2013?
Offer a very short reply. -13.21. What is the difference between the Primary completion rate (% of total enrollments) of Sub-Saharan Africa (developing only) in 2008 and the Primary completion rate (% of total enrollments) of Vanuatu in 2013?
Ensure brevity in your answer.  -35.43. What is the difference between the Primary completion rate (% of total enrollments) in Peru in 2008 and the Primary completion rate (% of total enrollments) in Togo in 2013?
Make the answer very short. 27.26. What is the difference between the Primary completion rate (% of total enrollments) in Peru in 2008 and the Primary completion rate (% of total enrollments) in Vanuatu in 2013?
Keep it short and to the point. 5.05. What is the difference between the Primary completion rate (% of total enrollments) in Togo in 2008 and the Primary completion rate (% of total enrollments) in Vanuatu in 2013?
Your answer should be compact. -40.58. What is the difference between the Primary completion rate (% of total enrollments) in Sub-Saharan Africa (developing only) in 2009 and the Primary completion rate (% of total enrollments) in Peru in 2010?
Make the answer very short. -36.1. What is the difference between the Primary completion rate (% of total enrollments) of Sub-Saharan Africa (developing only) in 2009 and the Primary completion rate (% of total enrollments) of Togo in 2010?
Your response must be concise. 1.51. What is the difference between the Primary completion rate (% of total enrollments) in Sub-Saharan Africa (developing only) in 2009 and the Primary completion rate (% of total enrollments) in Vanuatu in 2010?
Ensure brevity in your answer.  -23.43. What is the difference between the Primary completion rate (% of total enrollments) of Peru in 2009 and the Primary completion rate (% of total enrollments) of Togo in 2010?
Give a very brief answer. 36.3. What is the difference between the Primary completion rate (% of total enrollments) in Peru in 2009 and the Primary completion rate (% of total enrollments) in Vanuatu in 2010?
Offer a very short reply. 11.35. What is the difference between the Primary completion rate (% of total enrollments) in Togo in 2009 and the Primary completion rate (% of total enrollments) in Vanuatu in 2010?
Provide a succinct answer. -30.64. What is the difference between the Primary completion rate (% of total enrollments) of Sub-Saharan Africa (developing only) in 2009 and the Primary completion rate (% of total enrollments) of Peru in 2013?
Offer a very short reply. -29.25. What is the difference between the Primary completion rate (% of total enrollments) in Sub-Saharan Africa (developing only) in 2009 and the Primary completion rate (% of total enrollments) in Togo in 2013?
Keep it short and to the point. -10.88. What is the difference between the Primary completion rate (% of total enrollments) in Sub-Saharan Africa (developing only) in 2009 and the Primary completion rate (% of total enrollments) in Vanuatu in 2013?
Your answer should be compact. -33.09. What is the difference between the Primary completion rate (% of total enrollments) in Peru in 2009 and the Primary completion rate (% of total enrollments) in Togo in 2013?
Offer a terse response. 23.9. What is the difference between the Primary completion rate (% of total enrollments) in Peru in 2009 and the Primary completion rate (% of total enrollments) in Vanuatu in 2013?
Give a very brief answer. 1.69. What is the difference between the Primary completion rate (% of total enrollments) of Togo in 2009 and the Primary completion rate (% of total enrollments) of Vanuatu in 2013?
Provide a succinct answer. -40.3. What is the difference between the Primary completion rate (% of total enrollments) in Sub-Saharan Africa (developing only) in 2010 and the Primary completion rate (% of total enrollments) in Peru in 2013?
Offer a terse response. -28. What is the difference between the Primary completion rate (% of total enrollments) of Sub-Saharan Africa (developing only) in 2010 and the Primary completion rate (% of total enrollments) of Togo in 2013?
Your answer should be very brief. -9.63. What is the difference between the Primary completion rate (% of total enrollments) of Sub-Saharan Africa (developing only) in 2010 and the Primary completion rate (% of total enrollments) of Vanuatu in 2013?
Give a very brief answer. -31.84. What is the difference between the Primary completion rate (% of total enrollments) in Peru in 2010 and the Primary completion rate (% of total enrollments) in Togo in 2013?
Ensure brevity in your answer.  25.22. What is the difference between the Primary completion rate (% of total enrollments) in Peru in 2010 and the Primary completion rate (% of total enrollments) in Vanuatu in 2013?
Make the answer very short. 3.01. What is the difference between the Primary completion rate (% of total enrollments) of Togo in 2010 and the Primary completion rate (% of total enrollments) of Vanuatu in 2013?
Give a very brief answer. -34.61. What is the average Primary completion rate (% of total enrollments) in Sub-Saharan Africa (developing only) per year?
Provide a short and direct response. 58.55. What is the average Primary completion rate (% of total enrollments) of Peru per year?
Keep it short and to the point. 98.27. What is the average Primary completion rate (% of total enrollments) of Togo per year?
Ensure brevity in your answer.  59.03. What is the average Primary completion rate (% of total enrollments) in Vanuatu per year?
Ensure brevity in your answer.  92.16. In the year 2000, what is the difference between the Primary completion rate (% of total enrollments) of Sub-Saharan Africa (developing only) and Primary completion rate (% of total enrollments) of Peru?
Make the answer very short. -50.6. In the year 2000, what is the difference between the Primary completion rate (% of total enrollments) in Sub-Saharan Africa (developing only) and Primary completion rate (% of total enrollments) in Togo?
Your answer should be very brief. 1.2. In the year 2000, what is the difference between the Primary completion rate (% of total enrollments) of Sub-Saharan Africa (developing only) and Primary completion rate (% of total enrollments) of Vanuatu?
Give a very brief answer. -44.9. In the year 2000, what is the difference between the Primary completion rate (% of total enrollments) in Peru and Primary completion rate (% of total enrollments) in Togo?
Keep it short and to the point. 51.8. In the year 2000, what is the difference between the Primary completion rate (% of total enrollments) in Peru and Primary completion rate (% of total enrollments) in Vanuatu?
Your answer should be compact. 5.7. In the year 2000, what is the difference between the Primary completion rate (% of total enrollments) in Togo and Primary completion rate (% of total enrollments) in Vanuatu?
Offer a terse response. -46.1. In the year 2001, what is the difference between the Primary completion rate (% of total enrollments) in Sub-Saharan Africa (developing only) and Primary completion rate (% of total enrollments) in Peru?
Offer a very short reply. -44.79. In the year 2001, what is the difference between the Primary completion rate (% of total enrollments) in Sub-Saharan Africa (developing only) and Primary completion rate (% of total enrollments) in Togo?
Offer a very short reply. -4.37. In the year 2001, what is the difference between the Primary completion rate (% of total enrollments) in Sub-Saharan Africa (developing only) and Primary completion rate (% of total enrollments) in Vanuatu?
Keep it short and to the point. -54.78. In the year 2001, what is the difference between the Primary completion rate (% of total enrollments) of Peru and Primary completion rate (% of total enrollments) of Togo?
Your response must be concise. 40.42. In the year 2001, what is the difference between the Primary completion rate (% of total enrollments) in Peru and Primary completion rate (% of total enrollments) in Vanuatu?
Provide a succinct answer. -9.99. In the year 2001, what is the difference between the Primary completion rate (% of total enrollments) in Togo and Primary completion rate (% of total enrollments) in Vanuatu?
Offer a very short reply. -50.41. In the year 2004, what is the difference between the Primary completion rate (% of total enrollments) of Sub-Saharan Africa (developing only) and Primary completion rate (% of total enrollments) of Peru?
Your answer should be compact. -46.05. In the year 2004, what is the difference between the Primary completion rate (% of total enrollments) of Sub-Saharan Africa (developing only) and Primary completion rate (% of total enrollments) of Togo?
Provide a short and direct response. -7.21. In the year 2004, what is the difference between the Primary completion rate (% of total enrollments) in Sub-Saharan Africa (developing only) and Primary completion rate (% of total enrollments) in Vanuatu?
Offer a terse response. -35.87. In the year 2004, what is the difference between the Primary completion rate (% of total enrollments) of Peru and Primary completion rate (% of total enrollments) of Togo?
Your answer should be very brief. 38.84. In the year 2004, what is the difference between the Primary completion rate (% of total enrollments) in Peru and Primary completion rate (% of total enrollments) in Vanuatu?
Offer a terse response. 10.18. In the year 2004, what is the difference between the Primary completion rate (% of total enrollments) in Togo and Primary completion rate (% of total enrollments) in Vanuatu?
Offer a very short reply. -28.66. In the year 2008, what is the difference between the Primary completion rate (% of total enrollments) of Sub-Saharan Africa (developing only) and Primary completion rate (% of total enrollments) of Peru?
Ensure brevity in your answer.  -40.48. In the year 2008, what is the difference between the Primary completion rate (% of total enrollments) of Sub-Saharan Africa (developing only) and Primary completion rate (% of total enrollments) of Togo?
Your answer should be compact. 5.16. In the year 2008, what is the difference between the Primary completion rate (% of total enrollments) in Sub-Saharan Africa (developing only) and Primary completion rate (% of total enrollments) in Vanuatu?
Your answer should be very brief. -23.39. In the year 2008, what is the difference between the Primary completion rate (% of total enrollments) of Peru and Primary completion rate (% of total enrollments) of Togo?
Your response must be concise. 45.63. In the year 2008, what is the difference between the Primary completion rate (% of total enrollments) in Peru and Primary completion rate (% of total enrollments) in Vanuatu?
Your response must be concise. 17.09. In the year 2008, what is the difference between the Primary completion rate (% of total enrollments) in Togo and Primary completion rate (% of total enrollments) in Vanuatu?
Give a very brief answer. -28.54. In the year 2009, what is the difference between the Primary completion rate (% of total enrollments) in Sub-Saharan Africa (developing only) and Primary completion rate (% of total enrollments) in Peru?
Ensure brevity in your answer.  -34.78. In the year 2009, what is the difference between the Primary completion rate (% of total enrollments) in Sub-Saharan Africa (developing only) and Primary completion rate (% of total enrollments) in Togo?
Offer a very short reply. 7.21. In the year 2009, what is the difference between the Primary completion rate (% of total enrollments) of Sub-Saharan Africa (developing only) and Primary completion rate (% of total enrollments) of Vanuatu?
Provide a short and direct response. -23.82. In the year 2009, what is the difference between the Primary completion rate (% of total enrollments) of Peru and Primary completion rate (% of total enrollments) of Togo?
Your answer should be compact. 41.99. In the year 2009, what is the difference between the Primary completion rate (% of total enrollments) of Peru and Primary completion rate (% of total enrollments) of Vanuatu?
Your answer should be compact. 10.96. In the year 2009, what is the difference between the Primary completion rate (% of total enrollments) in Togo and Primary completion rate (% of total enrollments) in Vanuatu?
Ensure brevity in your answer.  -31.03. In the year 2010, what is the difference between the Primary completion rate (% of total enrollments) of Sub-Saharan Africa (developing only) and Primary completion rate (% of total enrollments) of Peru?
Your answer should be compact. -34.85. In the year 2010, what is the difference between the Primary completion rate (% of total enrollments) in Sub-Saharan Africa (developing only) and Primary completion rate (% of total enrollments) in Togo?
Offer a terse response. 2.77. In the year 2010, what is the difference between the Primary completion rate (% of total enrollments) in Sub-Saharan Africa (developing only) and Primary completion rate (% of total enrollments) in Vanuatu?
Your answer should be very brief. -22.18. In the year 2010, what is the difference between the Primary completion rate (% of total enrollments) of Peru and Primary completion rate (% of total enrollments) of Togo?
Offer a very short reply. 37.61. In the year 2010, what is the difference between the Primary completion rate (% of total enrollments) in Peru and Primary completion rate (% of total enrollments) in Vanuatu?
Keep it short and to the point. 12.67. In the year 2010, what is the difference between the Primary completion rate (% of total enrollments) of Togo and Primary completion rate (% of total enrollments) of Vanuatu?
Your response must be concise. -24.95. In the year 2013, what is the difference between the Primary completion rate (% of total enrollments) in Sub-Saharan Africa (developing only) and Primary completion rate (% of total enrollments) in Peru?
Offer a terse response. -26.46. In the year 2013, what is the difference between the Primary completion rate (% of total enrollments) in Sub-Saharan Africa (developing only) and Primary completion rate (% of total enrollments) in Togo?
Offer a very short reply. -8.09. In the year 2013, what is the difference between the Primary completion rate (% of total enrollments) in Sub-Saharan Africa (developing only) and Primary completion rate (% of total enrollments) in Vanuatu?
Your answer should be very brief. -30.3. In the year 2013, what is the difference between the Primary completion rate (% of total enrollments) of Peru and Primary completion rate (% of total enrollments) of Togo?
Your response must be concise. 18.37. In the year 2013, what is the difference between the Primary completion rate (% of total enrollments) of Peru and Primary completion rate (% of total enrollments) of Vanuatu?
Give a very brief answer. -3.84. In the year 2013, what is the difference between the Primary completion rate (% of total enrollments) in Togo and Primary completion rate (% of total enrollments) in Vanuatu?
Your answer should be very brief. -22.21. What is the ratio of the Primary completion rate (% of total enrollments) of Sub-Saharan Africa (developing only) in 2000 to that in 2001?
Keep it short and to the point. 0.97. What is the ratio of the Primary completion rate (% of total enrollments) in Peru in 2000 to that in 2001?
Your answer should be compact. 1.05. What is the ratio of the Primary completion rate (% of total enrollments) of Togo in 2000 to that in 2001?
Provide a short and direct response. 0.87. What is the ratio of the Primary completion rate (% of total enrollments) of Vanuatu in 2000 to that in 2001?
Your response must be concise. 0.89. What is the ratio of the Primary completion rate (% of total enrollments) in Sub-Saharan Africa (developing only) in 2000 to that in 2004?
Your response must be concise. 0.91. What is the ratio of the Primary completion rate (% of total enrollments) in Togo in 2000 to that in 2004?
Keep it short and to the point. 0.79. What is the ratio of the Primary completion rate (% of total enrollments) of Vanuatu in 2000 to that in 2004?
Provide a short and direct response. 1.05. What is the ratio of the Primary completion rate (% of total enrollments) of Sub-Saharan Africa (developing only) in 2000 to that in 2008?
Your answer should be very brief. 0.81. What is the ratio of the Primary completion rate (% of total enrollments) of Togo in 2000 to that in 2008?
Give a very brief answer. 0.87. What is the ratio of the Primary completion rate (% of total enrollments) in Vanuatu in 2000 to that in 2008?
Ensure brevity in your answer.  1.12. What is the ratio of the Primary completion rate (% of total enrollments) of Sub-Saharan Africa (developing only) in 2000 to that in 2009?
Your response must be concise. 0.78. What is the ratio of the Primary completion rate (% of total enrollments) in Peru in 2000 to that in 2009?
Give a very brief answer. 1.02. What is the ratio of the Primary completion rate (% of total enrollments) in Togo in 2000 to that in 2009?
Provide a short and direct response. 0.86. What is the ratio of the Primary completion rate (% of total enrollments) in Vanuatu in 2000 to that in 2009?
Give a very brief answer. 1.08. What is the ratio of the Primary completion rate (% of total enrollments) of Sub-Saharan Africa (developing only) in 2000 to that in 2010?
Offer a terse response. 0.77. What is the ratio of the Primary completion rate (% of total enrollments) in Peru in 2000 to that in 2010?
Ensure brevity in your answer.  1.01. What is the ratio of the Primary completion rate (% of total enrollments) in Togo in 2000 to that in 2010?
Your answer should be very brief. 0.78. What is the ratio of the Primary completion rate (% of total enrollments) in Vanuatu in 2000 to that in 2010?
Keep it short and to the point. 1.09. What is the ratio of the Primary completion rate (% of total enrollments) in Sub-Saharan Africa (developing only) in 2000 to that in 2013?
Give a very brief answer. 0.75. What is the ratio of the Primary completion rate (% of total enrollments) of Peru in 2000 to that in 2013?
Offer a very short reply. 1.08. What is the ratio of the Primary completion rate (% of total enrollments) in Togo in 2000 to that in 2013?
Keep it short and to the point. 0.65. What is the ratio of the Primary completion rate (% of total enrollments) in Vanuatu in 2000 to that in 2013?
Ensure brevity in your answer.  0.98. What is the ratio of the Primary completion rate (% of total enrollments) in Sub-Saharan Africa (developing only) in 2001 to that in 2004?
Provide a short and direct response. 0.94. What is the ratio of the Primary completion rate (% of total enrollments) in Peru in 2001 to that in 2004?
Make the answer very short. 0.95. What is the ratio of the Primary completion rate (% of total enrollments) in Togo in 2001 to that in 2004?
Ensure brevity in your answer.  0.9. What is the ratio of the Primary completion rate (% of total enrollments) in Vanuatu in 2001 to that in 2004?
Your response must be concise. 1.17. What is the ratio of the Primary completion rate (% of total enrollments) of Sub-Saharan Africa (developing only) in 2001 to that in 2008?
Give a very brief answer. 0.84. What is the ratio of the Primary completion rate (% of total enrollments) of Peru in 2001 to that in 2008?
Ensure brevity in your answer.  0.94. What is the ratio of the Primary completion rate (% of total enrollments) in Togo in 2001 to that in 2008?
Your answer should be compact. 0.99. What is the ratio of the Primary completion rate (% of total enrollments) in Vanuatu in 2001 to that in 2008?
Your answer should be compact. 1.25. What is the ratio of the Primary completion rate (% of total enrollments) of Sub-Saharan Africa (developing only) in 2001 to that in 2009?
Offer a terse response. 0.81. What is the ratio of the Primary completion rate (% of total enrollments) of Peru in 2001 to that in 2009?
Your answer should be compact. 0.98. What is the ratio of the Primary completion rate (% of total enrollments) of Togo in 2001 to that in 2009?
Ensure brevity in your answer.  0.99. What is the ratio of the Primary completion rate (% of total enrollments) of Vanuatu in 2001 to that in 2009?
Your answer should be very brief. 1.21. What is the ratio of the Primary completion rate (% of total enrollments) of Sub-Saharan Africa (developing only) in 2001 to that in 2010?
Keep it short and to the point. 0.79. What is the ratio of the Primary completion rate (% of total enrollments) in Peru in 2001 to that in 2010?
Make the answer very short. 0.96. What is the ratio of the Primary completion rate (% of total enrollments) of Togo in 2001 to that in 2010?
Provide a short and direct response. 0.9. What is the ratio of the Primary completion rate (% of total enrollments) of Vanuatu in 2001 to that in 2010?
Make the answer very short. 1.22. What is the ratio of the Primary completion rate (% of total enrollments) of Sub-Saharan Africa (developing only) in 2001 to that in 2013?
Your answer should be very brief. 0.77. What is the ratio of the Primary completion rate (% of total enrollments) in Peru in 2001 to that in 2013?
Your answer should be compact. 1.03. What is the ratio of the Primary completion rate (% of total enrollments) of Togo in 2001 to that in 2013?
Give a very brief answer. 0.75. What is the ratio of the Primary completion rate (% of total enrollments) of Vanuatu in 2001 to that in 2013?
Your answer should be compact. 1.1. What is the ratio of the Primary completion rate (% of total enrollments) of Sub-Saharan Africa (developing only) in 2004 to that in 2008?
Make the answer very short. 0.89. What is the ratio of the Primary completion rate (% of total enrollments) of Peru in 2004 to that in 2008?
Your answer should be compact. 0.99. What is the ratio of the Primary completion rate (% of total enrollments) in Togo in 2004 to that in 2008?
Your response must be concise. 1.1. What is the ratio of the Primary completion rate (% of total enrollments) of Vanuatu in 2004 to that in 2008?
Ensure brevity in your answer.  1.07. What is the ratio of the Primary completion rate (% of total enrollments) in Sub-Saharan Africa (developing only) in 2004 to that in 2009?
Provide a short and direct response. 0.86. What is the ratio of the Primary completion rate (% of total enrollments) of Peru in 2004 to that in 2009?
Ensure brevity in your answer.  1.02. What is the ratio of the Primary completion rate (% of total enrollments) in Togo in 2004 to that in 2009?
Provide a succinct answer. 1.1. What is the ratio of the Primary completion rate (% of total enrollments) of Vanuatu in 2004 to that in 2009?
Ensure brevity in your answer.  1.04. What is the ratio of the Primary completion rate (% of total enrollments) in Sub-Saharan Africa (developing only) in 2004 to that in 2010?
Provide a short and direct response. 0.84. What is the ratio of the Primary completion rate (% of total enrollments) in Peru in 2004 to that in 2010?
Make the answer very short. 1.01. What is the ratio of the Primary completion rate (% of total enrollments) of Vanuatu in 2004 to that in 2010?
Make the answer very short. 1.04. What is the ratio of the Primary completion rate (% of total enrollments) of Sub-Saharan Africa (developing only) in 2004 to that in 2013?
Provide a succinct answer. 0.82. What is the ratio of the Primary completion rate (% of total enrollments) of Peru in 2004 to that in 2013?
Offer a terse response. 1.08. What is the ratio of the Primary completion rate (% of total enrollments) in Togo in 2004 to that in 2013?
Make the answer very short. 0.83. What is the ratio of the Primary completion rate (% of total enrollments) in Vanuatu in 2004 to that in 2013?
Your answer should be very brief. 0.94. What is the ratio of the Primary completion rate (% of total enrollments) of Sub-Saharan Africa (developing only) in 2008 to that in 2009?
Your answer should be compact. 0.96. What is the ratio of the Primary completion rate (% of total enrollments) in Peru in 2008 to that in 2009?
Your response must be concise. 1.03. What is the ratio of the Primary completion rate (% of total enrollments) of Togo in 2008 to that in 2009?
Make the answer very short. 0.99. What is the ratio of the Primary completion rate (% of total enrollments) of Vanuatu in 2008 to that in 2009?
Give a very brief answer. 0.97. What is the ratio of the Primary completion rate (% of total enrollments) of Sub-Saharan Africa (developing only) in 2008 to that in 2010?
Offer a terse response. 0.94. What is the ratio of the Primary completion rate (% of total enrollments) in Peru in 2008 to that in 2010?
Keep it short and to the point. 1.02. What is the ratio of the Primary completion rate (% of total enrollments) in Togo in 2008 to that in 2010?
Offer a terse response. 0.9. What is the ratio of the Primary completion rate (% of total enrollments) in Vanuatu in 2008 to that in 2010?
Provide a succinct answer. 0.97. What is the ratio of the Primary completion rate (% of total enrollments) in Sub-Saharan Africa (developing only) in 2008 to that in 2013?
Offer a very short reply. 0.92. What is the ratio of the Primary completion rate (% of total enrollments) in Peru in 2008 to that in 2013?
Keep it short and to the point. 1.1. What is the ratio of the Primary completion rate (% of total enrollments) in Togo in 2008 to that in 2013?
Your answer should be compact. 0.75. What is the ratio of the Primary completion rate (% of total enrollments) of Vanuatu in 2008 to that in 2013?
Give a very brief answer. 0.88. What is the ratio of the Primary completion rate (% of total enrollments) of Sub-Saharan Africa (developing only) in 2009 to that in 2010?
Provide a succinct answer. 0.98. What is the ratio of the Primary completion rate (% of total enrollments) in Peru in 2009 to that in 2010?
Offer a terse response. 0.99. What is the ratio of the Primary completion rate (% of total enrollments) of Togo in 2009 to that in 2010?
Offer a terse response. 0.91. What is the ratio of the Primary completion rate (% of total enrollments) of Sub-Saharan Africa (developing only) in 2009 to that in 2013?
Your answer should be very brief. 0.96. What is the ratio of the Primary completion rate (% of total enrollments) in Peru in 2009 to that in 2013?
Your answer should be compact. 1.06. What is the ratio of the Primary completion rate (% of total enrollments) in Togo in 2009 to that in 2013?
Provide a short and direct response. 0.76. What is the ratio of the Primary completion rate (% of total enrollments) of Vanuatu in 2009 to that in 2013?
Make the answer very short. 0.9. What is the ratio of the Primary completion rate (% of total enrollments) in Sub-Saharan Africa (developing only) in 2010 to that in 2013?
Provide a succinct answer. 0.98. What is the ratio of the Primary completion rate (% of total enrollments) of Peru in 2010 to that in 2013?
Make the answer very short. 1.07. What is the ratio of the Primary completion rate (% of total enrollments) in Togo in 2010 to that in 2013?
Your answer should be very brief. 0.83. What is the ratio of the Primary completion rate (% of total enrollments) of Vanuatu in 2010 to that in 2013?
Provide a short and direct response. 0.9. What is the difference between the highest and the second highest Primary completion rate (% of total enrollments) of Sub-Saharan Africa (developing only)?
Offer a terse response. 1.54. What is the difference between the highest and the second highest Primary completion rate (% of total enrollments) of Peru?
Keep it short and to the point. 1.07. What is the difference between the highest and the second highest Primary completion rate (% of total enrollments) of Togo?
Give a very brief answer. 12.39. What is the difference between the highest and the second highest Primary completion rate (% of total enrollments) in Vanuatu?
Give a very brief answer. 9.34. What is the difference between the highest and the lowest Primary completion rate (% of total enrollments) in Sub-Saharan Africa (developing only)?
Keep it short and to the point. 16.57. What is the difference between the highest and the lowest Primary completion rate (% of total enrollments) of Peru?
Provide a short and direct response. 8.89. What is the difference between the highest and the lowest Primary completion rate (% of total enrollments) in Togo?
Keep it short and to the point. 25.86. What is the difference between the highest and the lowest Primary completion rate (% of total enrollments) of Vanuatu?
Offer a very short reply. 21.38. 